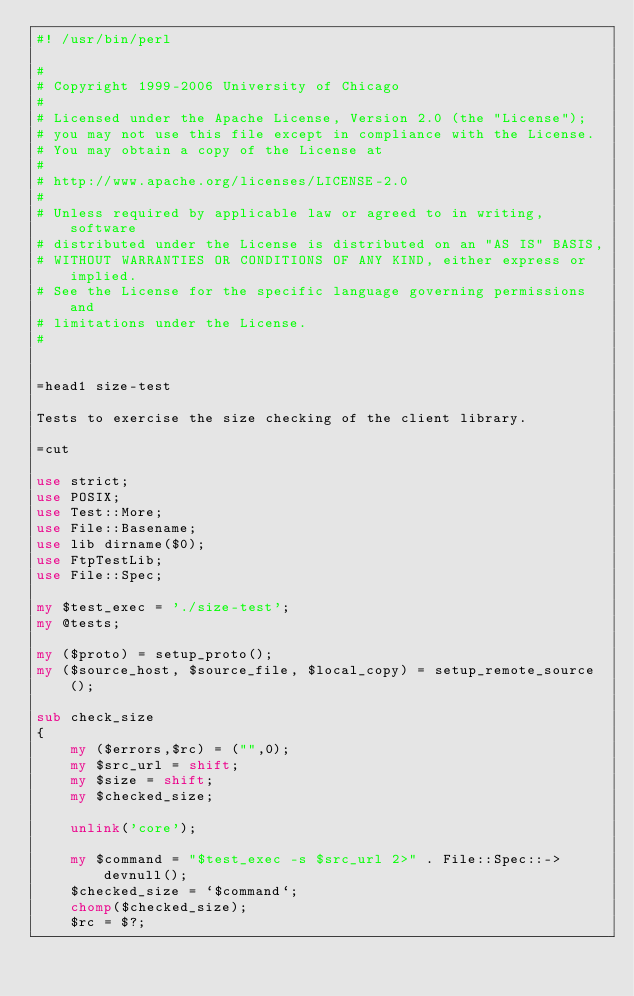<code> <loc_0><loc_0><loc_500><loc_500><_Perl_>#! /usr/bin/perl

# 
# Copyright 1999-2006 University of Chicago
# 
# Licensed under the Apache License, Version 2.0 (the "License");
# you may not use this file except in compliance with the License.
# You may obtain a copy of the License at
# 
# http://www.apache.org/licenses/LICENSE-2.0
# 
# Unless required by applicable law or agreed to in writing, software
# distributed under the License is distributed on an "AS IS" BASIS,
# WITHOUT WARRANTIES OR CONDITIONS OF ANY KIND, either express or implied.
# See the License for the specific language governing permissions and
# limitations under the License.
# 


=head1 size-test

Tests to exercise the size checking of the client library.

=cut

use strict;
use POSIX;
use Test::More;
use File::Basename;
use lib dirname($0);
use FtpTestLib;
use File::Spec;

my $test_exec = './size-test';
my @tests;

my ($proto) = setup_proto();
my ($source_host, $source_file, $local_copy) = setup_remote_source();

sub check_size
{
    my ($errors,$rc) = ("",0);
    my $src_url = shift;
    my $size = shift;
    my $checked_size;

    unlink('core');
    
    my $command = "$test_exec -s $src_url 2>" . File::Spec::->devnull();
    $checked_size = `$command`;
    chomp($checked_size);
    $rc = $?;</code> 